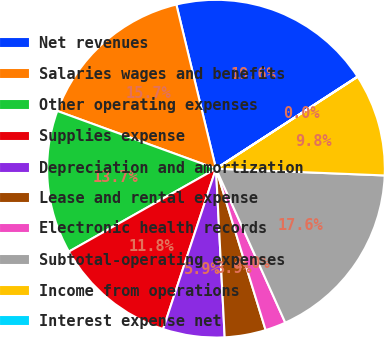Convert chart to OTSL. <chart><loc_0><loc_0><loc_500><loc_500><pie_chart><fcel>Net revenues<fcel>Salaries wages and benefits<fcel>Other operating expenses<fcel>Supplies expense<fcel>Depreciation and amortization<fcel>Lease and rental expense<fcel>Electronic health records<fcel>Subtotal-operating expenses<fcel>Income from operations<fcel>Interest expense net<nl><fcel>19.59%<fcel>15.68%<fcel>13.72%<fcel>11.76%<fcel>5.89%<fcel>3.93%<fcel>1.98%<fcel>17.63%<fcel>9.8%<fcel>0.02%<nl></chart> 